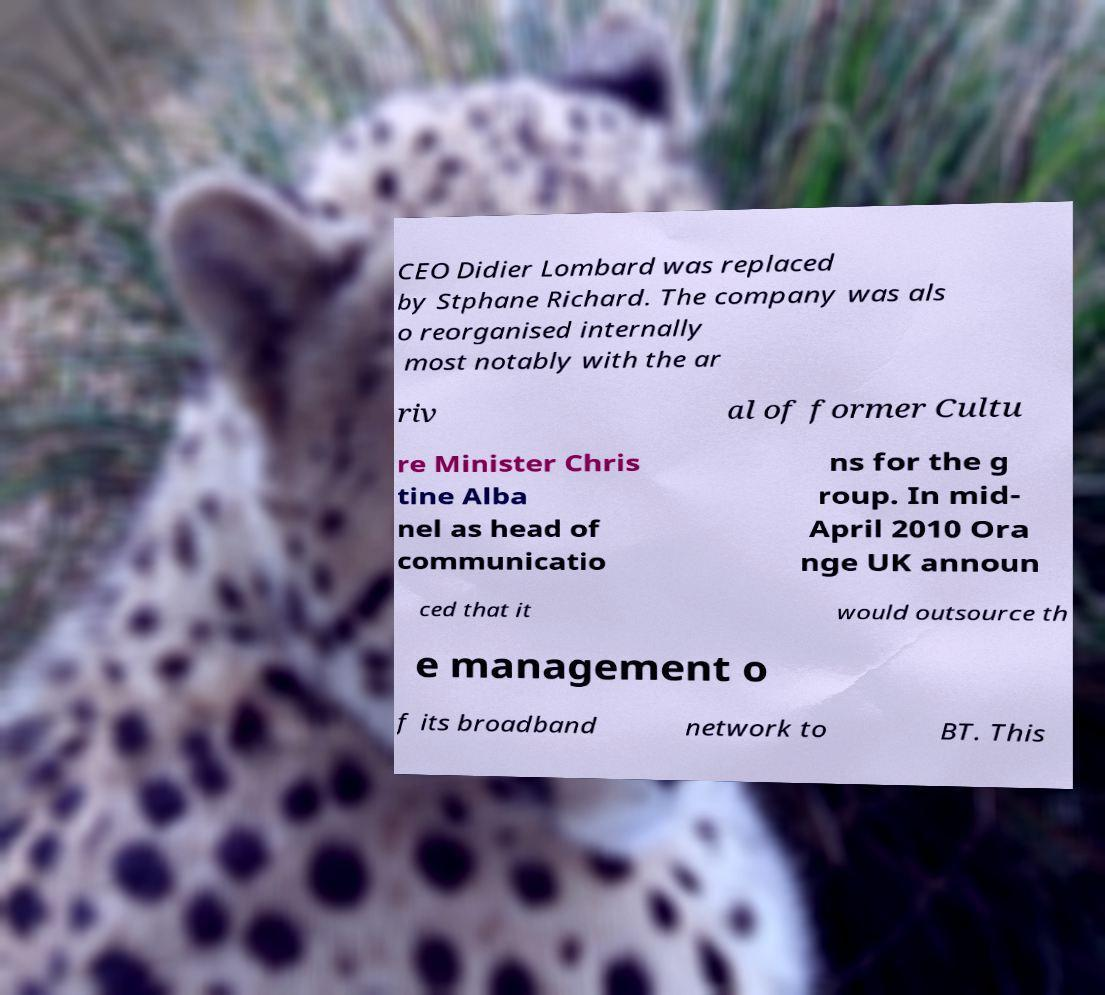There's text embedded in this image that I need extracted. Can you transcribe it verbatim? CEO Didier Lombard was replaced by Stphane Richard. The company was als o reorganised internally most notably with the ar riv al of former Cultu re Minister Chris tine Alba nel as head of communicatio ns for the g roup. In mid- April 2010 Ora nge UK announ ced that it would outsource th e management o f its broadband network to BT. This 